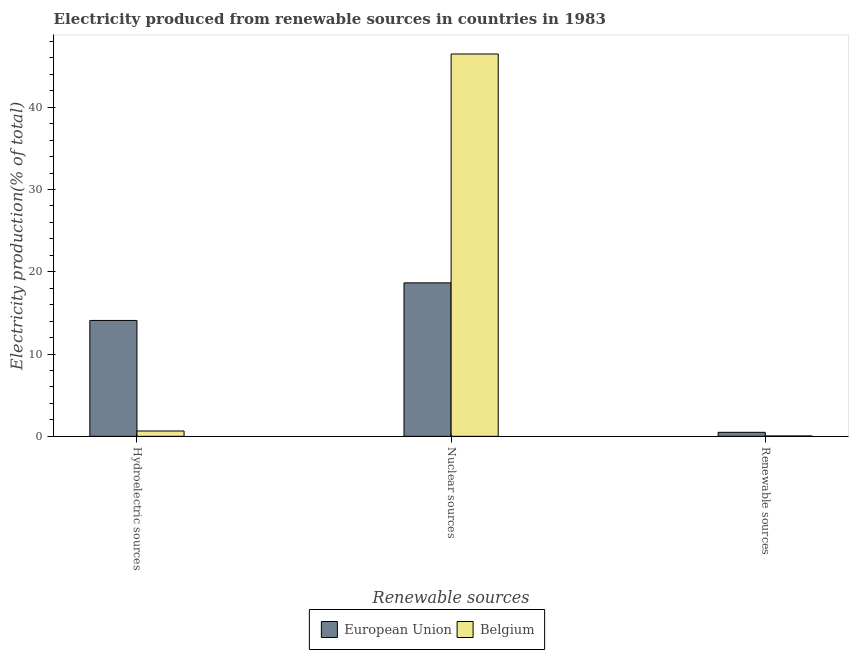How many different coloured bars are there?
Offer a terse response. 2. What is the label of the 2nd group of bars from the left?
Your answer should be very brief. Nuclear sources. What is the percentage of electricity produced by nuclear sources in Belgium?
Keep it short and to the point. 46.47. Across all countries, what is the maximum percentage of electricity produced by nuclear sources?
Provide a short and direct response. 46.47. Across all countries, what is the minimum percentage of electricity produced by nuclear sources?
Ensure brevity in your answer.  18.65. In which country was the percentage of electricity produced by hydroelectric sources minimum?
Your answer should be compact. Belgium. What is the total percentage of electricity produced by renewable sources in the graph?
Your answer should be very brief. 0.53. What is the difference between the percentage of electricity produced by renewable sources in Belgium and that in European Union?
Offer a terse response. -0.44. What is the difference between the percentage of electricity produced by renewable sources in European Union and the percentage of electricity produced by nuclear sources in Belgium?
Ensure brevity in your answer.  -45.99. What is the average percentage of electricity produced by hydroelectric sources per country?
Provide a succinct answer. 7.37. What is the difference between the percentage of electricity produced by nuclear sources and percentage of electricity produced by renewable sources in Belgium?
Ensure brevity in your answer.  46.43. In how many countries, is the percentage of electricity produced by renewable sources greater than 28 %?
Your answer should be compact. 0. What is the ratio of the percentage of electricity produced by renewable sources in Belgium to that in European Union?
Keep it short and to the point. 0.09. Is the percentage of electricity produced by nuclear sources in Belgium less than that in European Union?
Your response must be concise. No. Is the difference between the percentage of electricity produced by nuclear sources in Belgium and European Union greater than the difference between the percentage of electricity produced by renewable sources in Belgium and European Union?
Provide a short and direct response. Yes. What is the difference between the highest and the second highest percentage of electricity produced by nuclear sources?
Your response must be concise. 27.82. What is the difference between the highest and the lowest percentage of electricity produced by nuclear sources?
Provide a succinct answer. 27.82. What does the 2nd bar from the left in Hydroelectric sources represents?
Your answer should be very brief. Belgium. How many bars are there?
Offer a very short reply. 6. Are all the bars in the graph horizontal?
Ensure brevity in your answer.  No. How many countries are there in the graph?
Ensure brevity in your answer.  2. Does the graph contain any zero values?
Offer a very short reply. No. Does the graph contain grids?
Make the answer very short. No. Where does the legend appear in the graph?
Provide a short and direct response. Bottom center. How many legend labels are there?
Your answer should be very brief. 2. What is the title of the graph?
Your answer should be compact. Electricity produced from renewable sources in countries in 1983. What is the label or title of the X-axis?
Your response must be concise. Renewable sources. What is the Electricity production(% of total) in European Union in Hydroelectric sources?
Keep it short and to the point. 14.09. What is the Electricity production(% of total) of Belgium in Hydroelectric sources?
Provide a short and direct response. 0.65. What is the Electricity production(% of total) of European Union in Nuclear sources?
Your answer should be compact. 18.65. What is the Electricity production(% of total) of Belgium in Nuclear sources?
Provide a succinct answer. 46.47. What is the Electricity production(% of total) of European Union in Renewable sources?
Give a very brief answer. 0.49. What is the Electricity production(% of total) of Belgium in Renewable sources?
Give a very brief answer. 0.04. Across all Renewable sources, what is the maximum Electricity production(% of total) in European Union?
Your answer should be compact. 18.65. Across all Renewable sources, what is the maximum Electricity production(% of total) of Belgium?
Provide a short and direct response. 46.47. Across all Renewable sources, what is the minimum Electricity production(% of total) in European Union?
Your answer should be compact. 0.49. Across all Renewable sources, what is the minimum Electricity production(% of total) of Belgium?
Make the answer very short. 0.04. What is the total Electricity production(% of total) in European Union in the graph?
Provide a succinct answer. 33.22. What is the total Electricity production(% of total) in Belgium in the graph?
Your answer should be very brief. 47.16. What is the difference between the Electricity production(% of total) in European Union in Hydroelectric sources and that in Nuclear sources?
Give a very brief answer. -4.57. What is the difference between the Electricity production(% of total) in Belgium in Hydroelectric sources and that in Nuclear sources?
Offer a terse response. -45.83. What is the difference between the Electricity production(% of total) of European Union in Hydroelectric sources and that in Renewable sources?
Provide a succinct answer. 13.6. What is the difference between the Electricity production(% of total) in Belgium in Hydroelectric sources and that in Renewable sources?
Keep it short and to the point. 0.61. What is the difference between the Electricity production(% of total) of European Union in Nuclear sources and that in Renewable sources?
Your answer should be very brief. 18.17. What is the difference between the Electricity production(% of total) of Belgium in Nuclear sources and that in Renewable sources?
Your answer should be compact. 46.43. What is the difference between the Electricity production(% of total) of European Union in Hydroelectric sources and the Electricity production(% of total) of Belgium in Nuclear sources?
Provide a short and direct response. -32.39. What is the difference between the Electricity production(% of total) in European Union in Hydroelectric sources and the Electricity production(% of total) in Belgium in Renewable sources?
Offer a terse response. 14.04. What is the difference between the Electricity production(% of total) of European Union in Nuclear sources and the Electricity production(% of total) of Belgium in Renewable sources?
Provide a succinct answer. 18.61. What is the average Electricity production(% of total) in European Union per Renewable sources?
Keep it short and to the point. 11.07. What is the average Electricity production(% of total) in Belgium per Renewable sources?
Your answer should be very brief. 15.72. What is the difference between the Electricity production(% of total) in European Union and Electricity production(% of total) in Belgium in Hydroelectric sources?
Ensure brevity in your answer.  13.44. What is the difference between the Electricity production(% of total) in European Union and Electricity production(% of total) in Belgium in Nuclear sources?
Offer a terse response. -27.82. What is the difference between the Electricity production(% of total) in European Union and Electricity production(% of total) in Belgium in Renewable sources?
Offer a terse response. 0.44. What is the ratio of the Electricity production(% of total) of European Union in Hydroelectric sources to that in Nuclear sources?
Your answer should be compact. 0.76. What is the ratio of the Electricity production(% of total) in Belgium in Hydroelectric sources to that in Nuclear sources?
Your answer should be very brief. 0.01. What is the ratio of the Electricity production(% of total) of European Union in Hydroelectric sources to that in Renewable sources?
Keep it short and to the point. 28.98. What is the ratio of the Electricity production(% of total) of Belgium in Hydroelectric sources to that in Renewable sources?
Offer a very short reply. 15.27. What is the ratio of the Electricity production(% of total) of European Union in Nuclear sources to that in Renewable sources?
Provide a short and direct response. 38.38. What is the ratio of the Electricity production(% of total) in Belgium in Nuclear sources to that in Renewable sources?
Provide a short and direct response. 1095.73. What is the difference between the highest and the second highest Electricity production(% of total) in European Union?
Your answer should be compact. 4.57. What is the difference between the highest and the second highest Electricity production(% of total) in Belgium?
Offer a terse response. 45.83. What is the difference between the highest and the lowest Electricity production(% of total) in European Union?
Provide a succinct answer. 18.17. What is the difference between the highest and the lowest Electricity production(% of total) of Belgium?
Offer a very short reply. 46.43. 